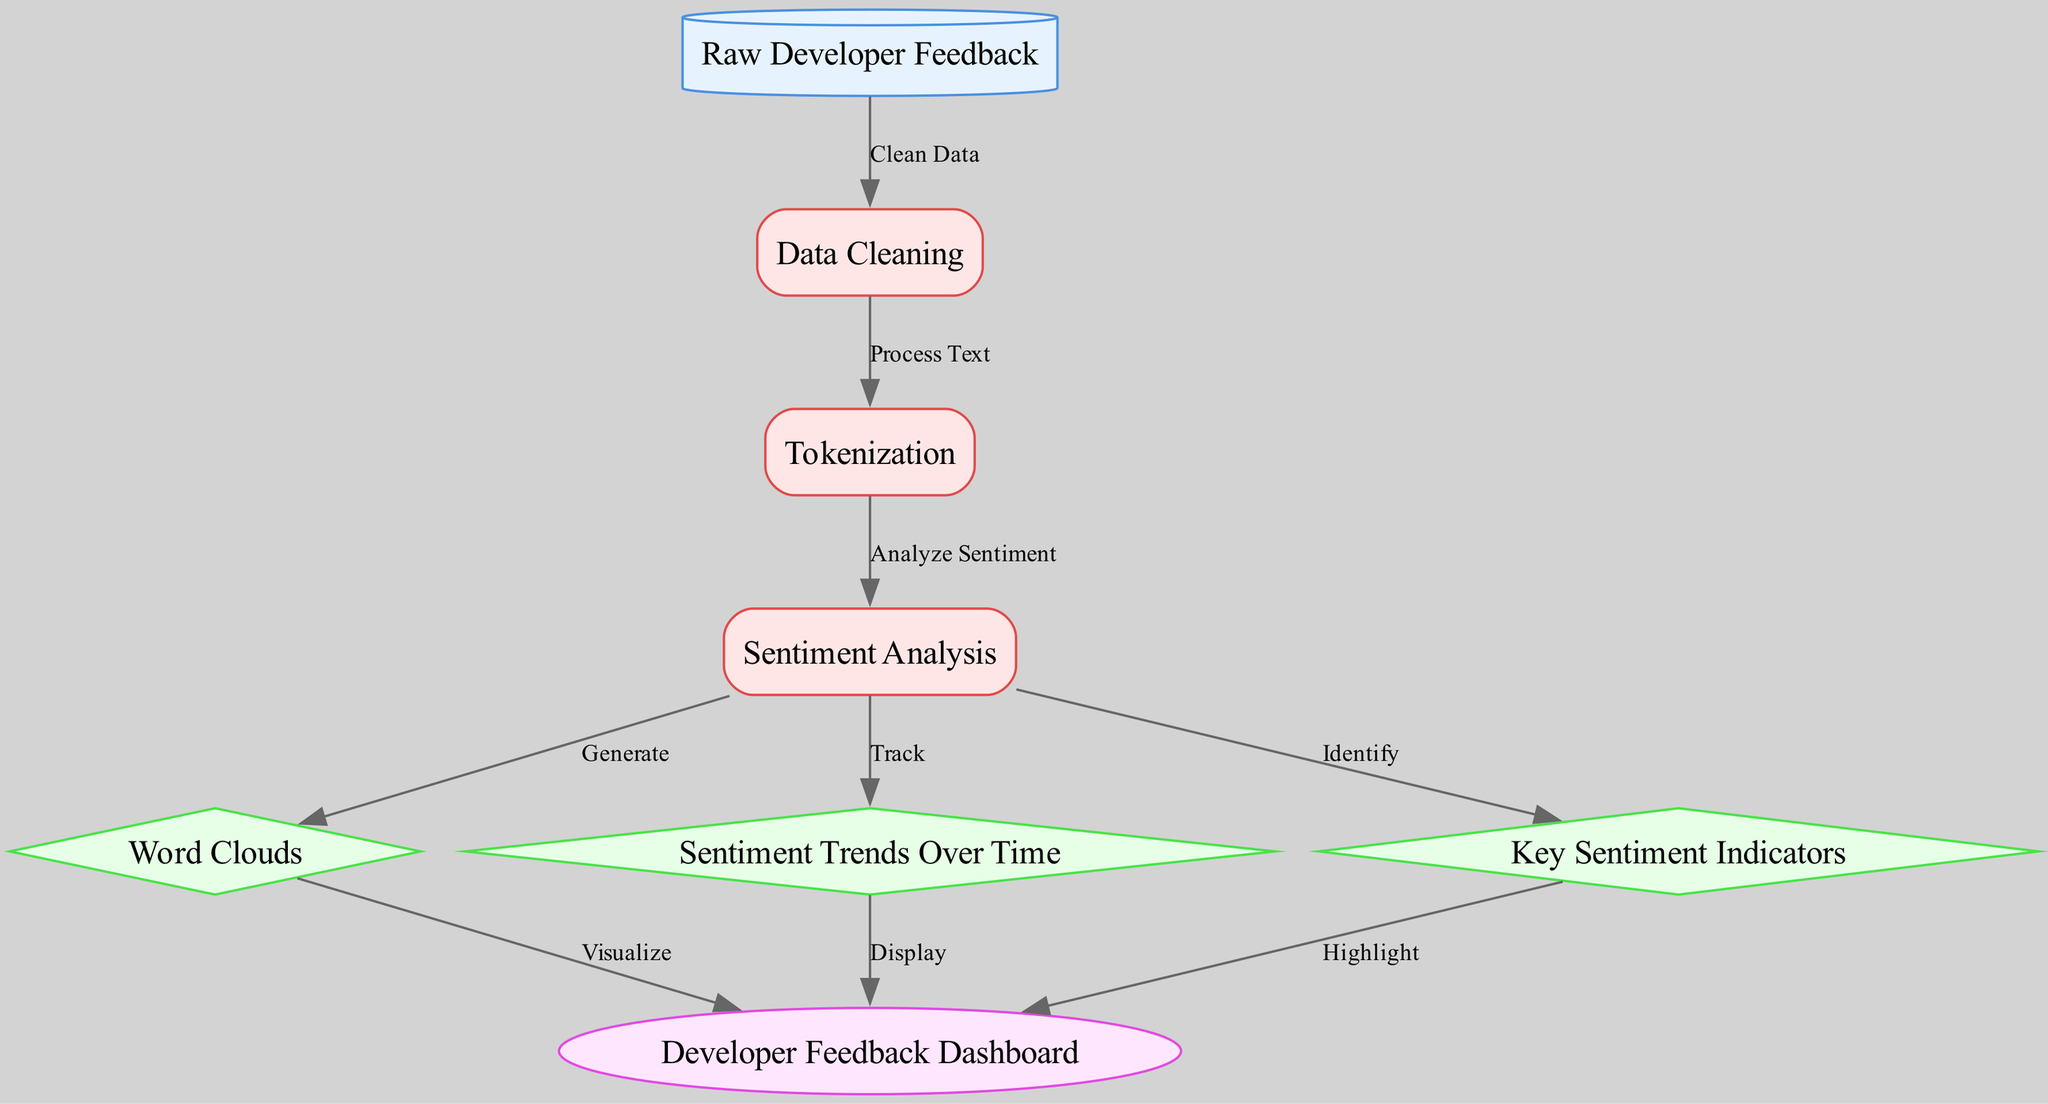What is the first node in the diagram? The first node represents the starting point of the process, which in this case is labeled "Raw Developer Feedback."
Answer: Raw Developer Feedback How many visualization nodes are there in the diagram? There are three visualization nodes: "Word Clouds," "Sentiment Trends Over Time," and "Key Sentiment Indicators."
Answer: 3 What process follows the "Data Cleaning" node? After "Data Cleaning," the next process is "Tokenization," which processes the cleaned data for analysis.
Answer: Tokenization Which node generates word clouds? The "Word Clouds" node is directly fed by the "Sentiment Analysis" process, which analyzes the sentiment of the feedback.
Answer: Word Clouds What is the final output node in the diagram? The last node that serves as the output from the entire process is the "Developer Feedback Dashboard."
Answer: Developer Feedback Dashboard Which node represents a data source? The "Raw Developer Feedback" node is classified as a data source, indicating its role in providing initial input for the analysis.
Answer: Raw Developer Feedback What is the relationship between "Sentiment Analysis" and "Sentiment Trends Over Time"? "Sentiment Trends Over Time" receives data directly from the "Sentiment Analysis" node, indicating that it tracks the results of sentiment analysis over time.
Answer: Track How are the "Key Sentiment Indicators" used in the final output? The "Key Sentiment Indicators" node identifies important metrics from sentiment analysis that are highlighted in the final output, contributing to the overall dashboard view.
Answer: Highlight 